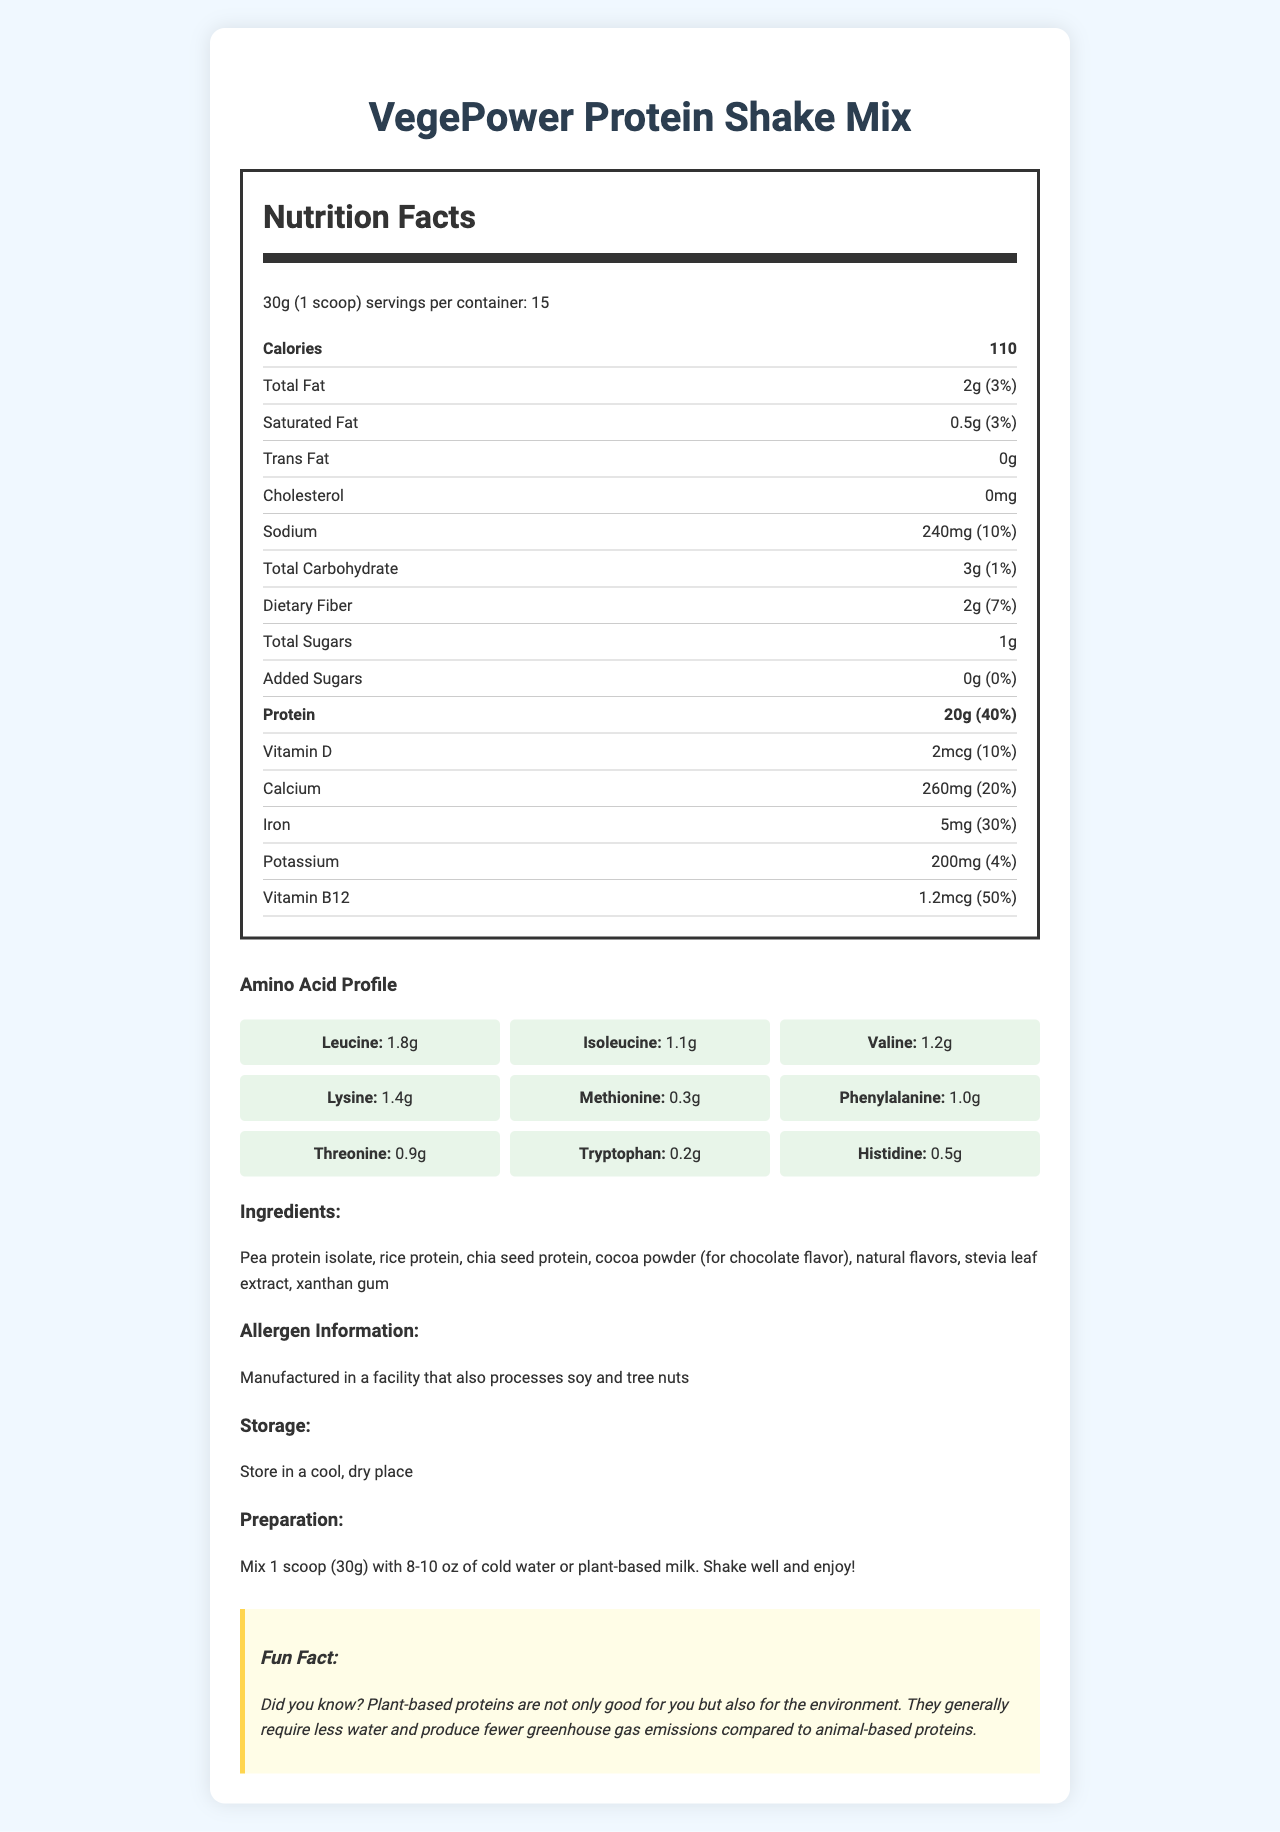what is the serving size for VegePower Protein Shake Mix? The serving size is clearly listed as 30g (1 scoop) in the document.
Answer: 30g (1 scoop) how many servings are there per container? The document states that there are 15 servings per container.
Answer: 15 how many calories are in one scoop? The document lists the calorie content as 110 calories per serving.
Answer: 110 what is the amount of protein per serving? The document specifies that there are 20 grams of protein per serving.
Answer: 20g how much Vitamin D is in one serving? The label indicates that each serving contains 2 micrograms of Vitamin D.
Answer: 2mcg what percentage of the daily value of iron does one serving provide? The document shows that one serving provides 30% of the daily value of iron.
Answer: 30% how many grams of dietary fiber are in one serving? The document lists 2 grams of dietary fiber per serving.
Answer: 2g does the protein shake mix contain any added sugars? The document clearly states that there are 0 grams of added sugars.
Answer: No what is one of the sources of protein in this mix? The ingredients section lists pea protein isolate as one of the sources of protein.
Answer: Pea protein isolate which amino acid is present in the highest amount? A. Leucine B. Isoleucine C. Methionine D. Tryptophan Leucine is listed as having 1.8g per serving, which is higher than the amounts for other amino acids.
Answer: A which of the following is NOT an ingredient in the protein shake mix? A. Pea protein isolate B. Rice protein C. Coconut oil D. Chia seed protein Coconut oil is not listed among the ingredients; the document lists pea protein isolate, rice protein, and chia seed protein instead.
Answer: C is there any cholesterol in this protein shake mix? The document indicates that there is 0mg of cholesterol per serving.
Answer: No how can you prepare the VegePower Protein Shake Mix? The preparation instructions clearly state to mix 1 scoop with 8-10 oz of cold water or plant-based milk, shake well, and enjoy.
Answer: Mix 1 scoop (30g) with 8-10 oz of cold water or plant-based milk. Shake well and enjoy! where should you store the protein shake powder? The storage instructions specify to store the product in a cool, dry place.
Answer: In a cool, dry place what is the main idea of this document? The document aims to inform the consumer about the nutritional value, ingredients, method of preparation, storage guidelines, and an interesting environmental benefit associated with the product.
Answer: The document provides the nutrition facts, ingredients, preparation instructions, storage information, and a fun environmental fact about the VegePower Protein Shake Mix. what is the exact amount of each vitamin in one serving? The document only provides values for Vitamin D (2mcg) and Vitamin B12 (1.2mcg) but does not specify other vitamins.
Answer: I don't know 